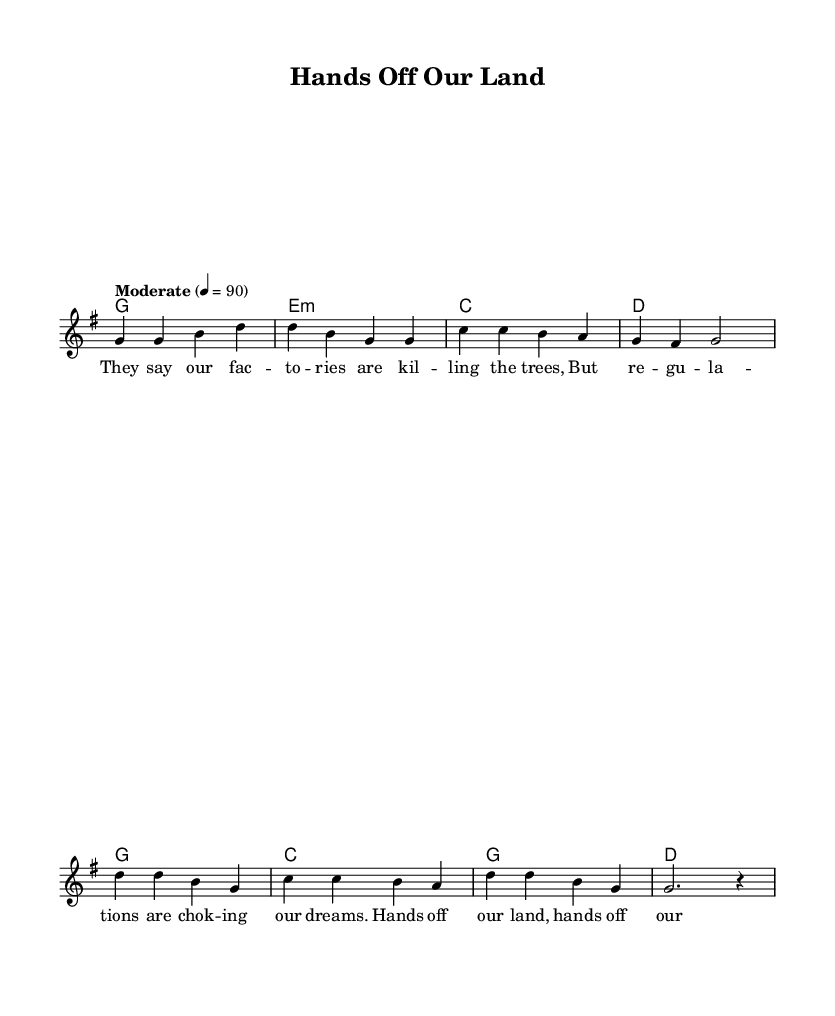What is the key signature of this music? The key signature indicated in the music is G major, which has one sharp. You can identify the key signature by the symbols at the beginning of the staff.
Answer: G major What is the time signature of this music? The time signature of the piece is 4/4, which means there are four beats in each measure. This is visible in the notation right at the beginning of the score.
Answer: 4/4 What is the tempo marking indicated in the sheet music? The tempo marking is "Moderate" with a metronome marking of 90. This can be found written at the beginning of the score under the tempo section.
Answer: Moderate, 90 How many measures are in the verse section? The verse section consists of four measures. You can count the measures by looking for vertical lines that separate the groups of notes in the melody.
Answer: Four What is the name of the song? The title of the song is "Hands Off Our Land," as indicated at the top of the sheet music in the header section.
Answer: Hands Off Our Land Which chord appears first in the harmonies? The first chord in the harmonies is G major. This can be determined by looking at the first chord symbol written above the staff in the harmonies section.
Answer: G How many lines of lyrics are in the verse? There are four lines of lyrics in the verse section. This can be counted by examining the lyric lines under the notes in the melody section.
Answer: Four 